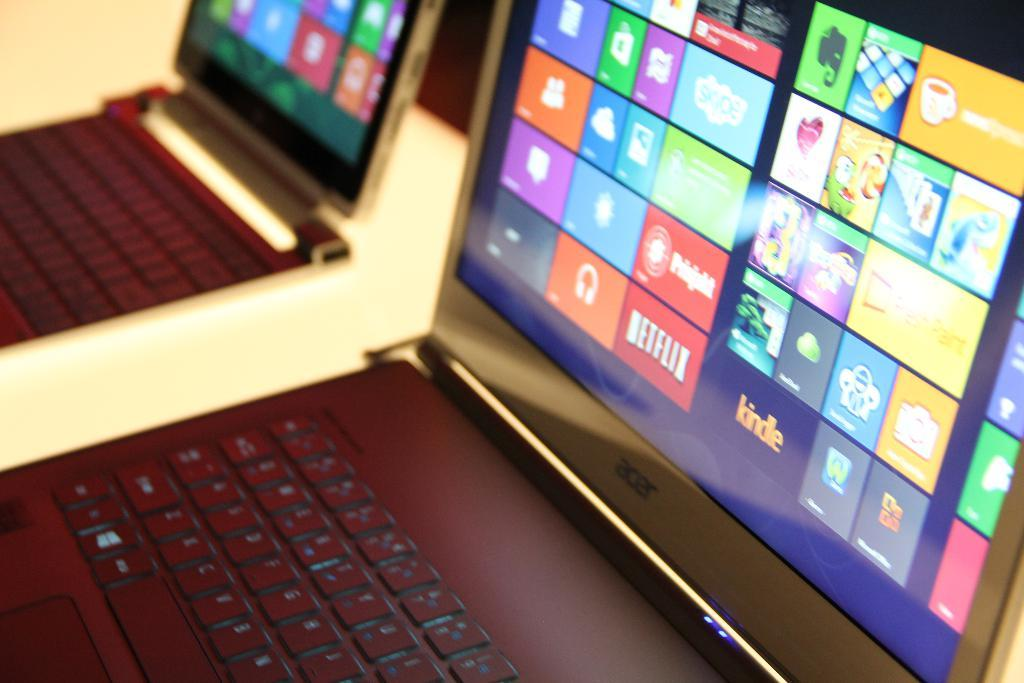<image>
Offer a succinct explanation of the picture presented. An opened laptop displays a screen featuring apps, such as Netflix. 